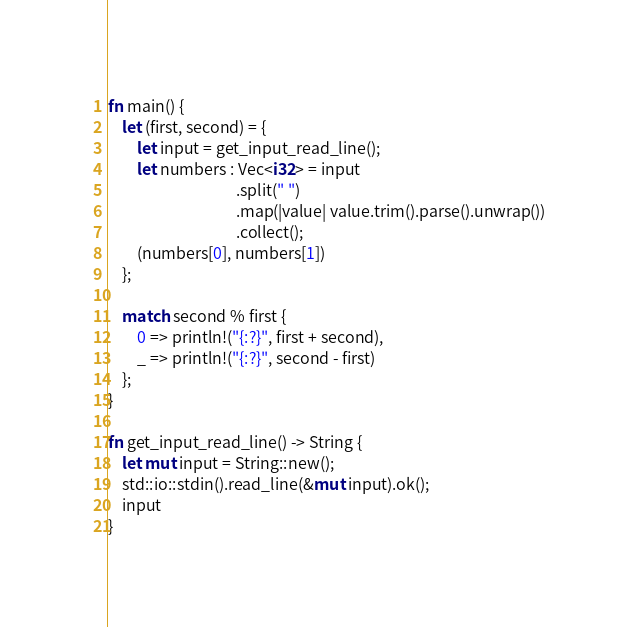Convert code to text. <code><loc_0><loc_0><loc_500><loc_500><_Rust_>fn main() {
    let (first, second) = {
        let input = get_input_read_line();
        let numbers : Vec<i32> = input
                                    .split(" ")
                                    .map(|value| value.trim().parse().unwrap())
                                    .collect();
        (numbers[0], numbers[1])
    };

    match second % first {
        0 => println!("{:?}", first + second),
        _ => println!("{:?}", second - first)
    };
}

fn get_input_read_line() -> String {
    let mut input = String::new();
    std::io::stdin().read_line(&mut input).ok();
    input
}
</code> 